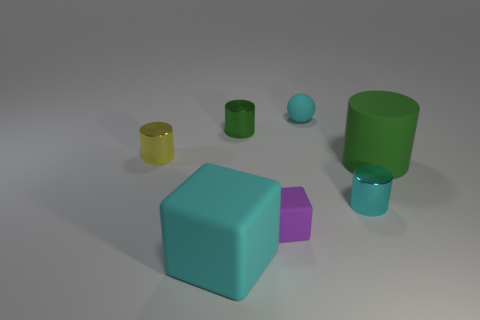Subtract all yellow cubes. How many green cylinders are left? 2 Subtract all yellow metal cylinders. How many cylinders are left? 3 Add 1 small cylinders. How many objects exist? 8 Subtract 1 cylinders. How many cylinders are left? 3 Subtract all yellow cylinders. How many cylinders are left? 3 Subtract all gray cylinders. Subtract all green spheres. How many cylinders are left? 4 Subtract all gray shiny blocks. Subtract all blocks. How many objects are left? 5 Add 7 cyan balls. How many cyan balls are left? 8 Add 2 cyan cylinders. How many cyan cylinders exist? 3 Subtract 0 purple spheres. How many objects are left? 7 